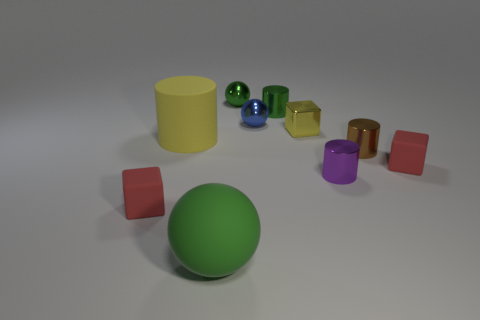Subtract all matte blocks. How many blocks are left? 1 Subtract all cylinders. How many objects are left? 6 Subtract 2 cylinders. How many cylinders are left? 2 Subtract all blue balls. How many balls are left? 2 Subtract all brown cylinders. How many yellow spheres are left? 0 Subtract all tiny yellow metallic cubes. Subtract all large yellow cylinders. How many objects are left? 8 Add 8 blue shiny balls. How many blue shiny balls are left? 9 Add 5 green objects. How many green objects exist? 8 Subtract 0 cyan spheres. How many objects are left? 10 Subtract all brown cubes. Subtract all green cylinders. How many cubes are left? 3 